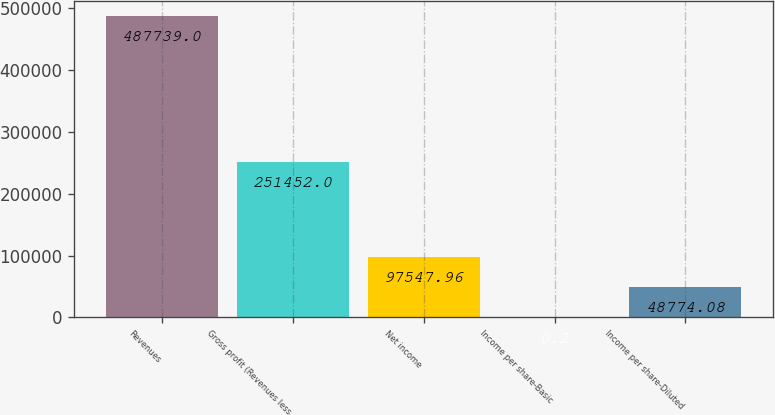Convert chart. <chart><loc_0><loc_0><loc_500><loc_500><bar_chart><fcel>Revenues<fcel>Gross profit (Revenues less<fcel>Net income<fcel>Income per share-Basic<fcel>Income per share-Diluted<nl><fcel>487739<fcel>251452<fcel>97548<fcel>0.2<fcel>48774.1<nl></chart> 